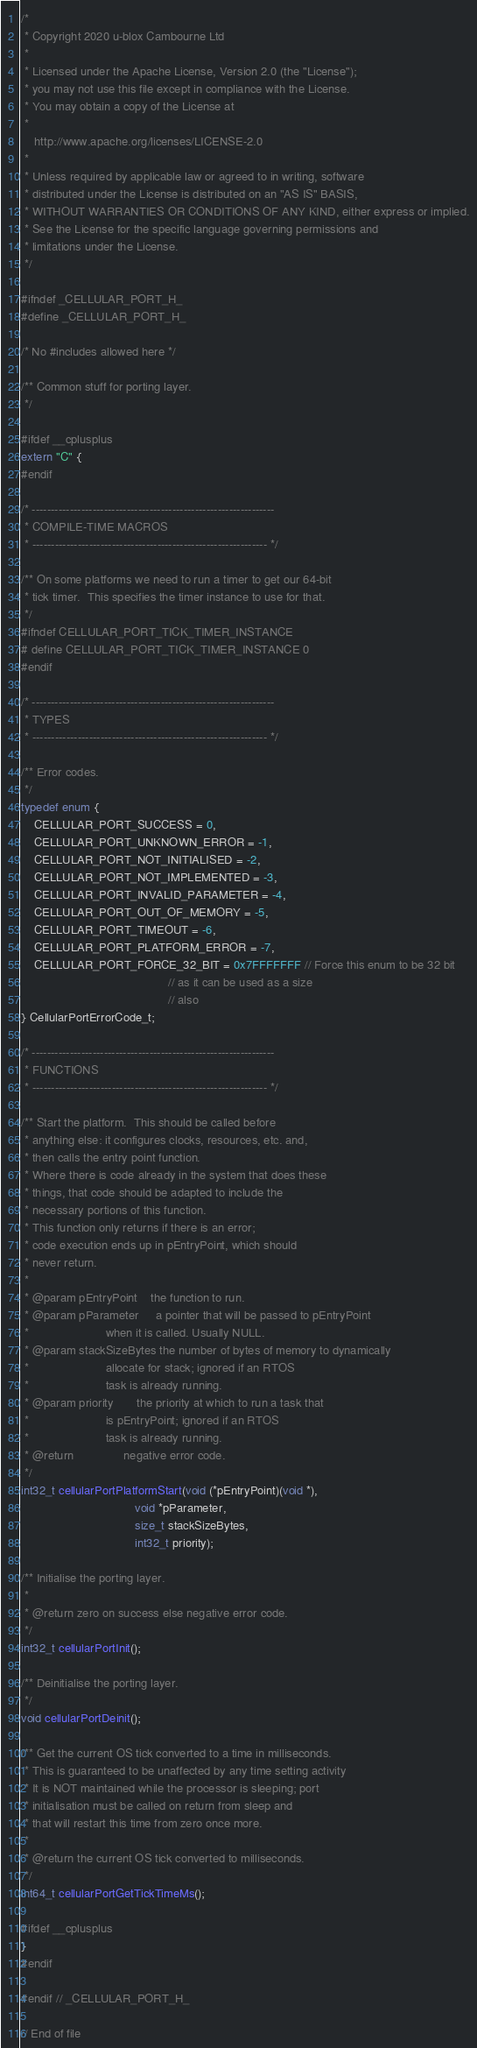<code> <loc_0><loc_0><loc_500><loc_500><_C_>/*
 * Copyright 2020 u-blox Cambourne Ltd
 *
 * Licensed under the Apache License, Version 2.0 (the "License");
 * you may not use this file except in compliance with the License.
 * You may obtain a copy of the License at
 * 
    http://www.apache.org/licenses/LICENSE-2.0
 * 
 * Unless required by applicable law or agreed to in writing, software
 * distributed under the License is distributed on an "AS IS" BASIS,
 * WITHOUT WARRANTIES OR CONDITIONS OF ANY KIND, either express or implied.
 * See the License for the specific language governing permissions and
 * limitations under the License.
 */

#ifndef _CELLULAR_PORT_H_
#define _CELLULAR_PORT_H_

/* No #includes allowed here */

/** Common stuff for porting layer.
 */

#ifdef __cplusplus
extern "C" {
#endif

/* ----------------------------------------------------------------
 * COMPILE-TIME MACROS
 * -------------------------------------------------------------- */

/** On some platforms we need to run a timer to get our 64-bit
 * tick timer.  This specifies the timer instance to use for that.
 */
#ifndef CELLULAR_PORT_TICK_TIMER_INSTANCE
# define CELLULAR_PORT_TICK_TIMER_INSTANCE 0
#endif

/* ----------------------------------------------------------------
 * TYPES
 * -------------------------------------------------------------- */

/** Error codes.
 */
typedef enum {
    CELLULAR_PORT_SUCCESS = 0,
    CELLULAR_PORT_UNKNOWN_ERROR = -1,
    CELLULAR_PORT_NOT_INITIALISED = -2,
    CELLULAR_PORT_NOT_IMPLEMENTED = -3,
    CELLULAR_PORT_INVALID_PARAMETER = -4,
    CELLULAR_PORT_OUT_OF_MEMORY = -5,
    CELLULAR_PORT_TIMEOUT = -6,
    CELLULAR_PORT_PLATFORM_ERROR = -7,
    CELLULAR_PORT_FORCE_32_BIT = 0x7FFFFFFF // Force this enum to be 32 bit
                                            // as it can be used as a size
                                            // also
} CellularPortErrorCode_t;

/* ----------------------------------------------------------------
 * FUNCTIONS
 * -------------------------------------------------------------- */

/** Start the platform.  This should be called before
 * anything else: it configures clocks, resources, etc. and,
 * then calls the entry point function.
 * Where there is code already in the system that does these
 * things, that code should be adapted to include the
 * necessary portions of this function.
 * This function only returns if there is an error;
 * code execution ends up in pEntryPoint, which should 
 * never return.
 *
 * @param pEntryPoint    the function to run.
 * @param pParameter     a pointer that will be passed to pEntryPoint
 *                       when it is called. Usually NULL.
 * @param stackSizeBytes the number of bytes of memory to dynamically
 *                       allocate for stack; ignored if an RTOS
 *                       task is already running.
 * @param priority       the priority at which to run a task that
 *                       is pEntryPoint; ignored if an RTOS
 *                       task is already running.
 * @return               negative error code.
 */
int32_t cellularPortPlatformStart(void (*pEntryPoint)(void *),
                                  void *pParameter,
                                  size_t stackSizeBytes,
                                  int32_t priority);

/** Initialise the porting layer.
 *
 * @return zero on success else negative error code.
 */
int32_t cellularPortInit();

/** Deinitialise the porting layer.
 */
void cellularPortDeinit();

/** Get the current OS tick converted to a time in milliseconds.
 * This is guaranteed to be unaffected by any time setting activity
 * It is NOT maintained while the processor is sleeping; port
 * initialisation must be called on return from sleep and
 * that will restart this time from zero once more.
 *
 * @return the current OS tick converted to milliseconds.
 */
int64_t cellularPortGetTickTimeMs();

#ifdef __cplusplus
}
#endif

#endif // _CELLULAR_PORT_H_

// End of file
</code> 